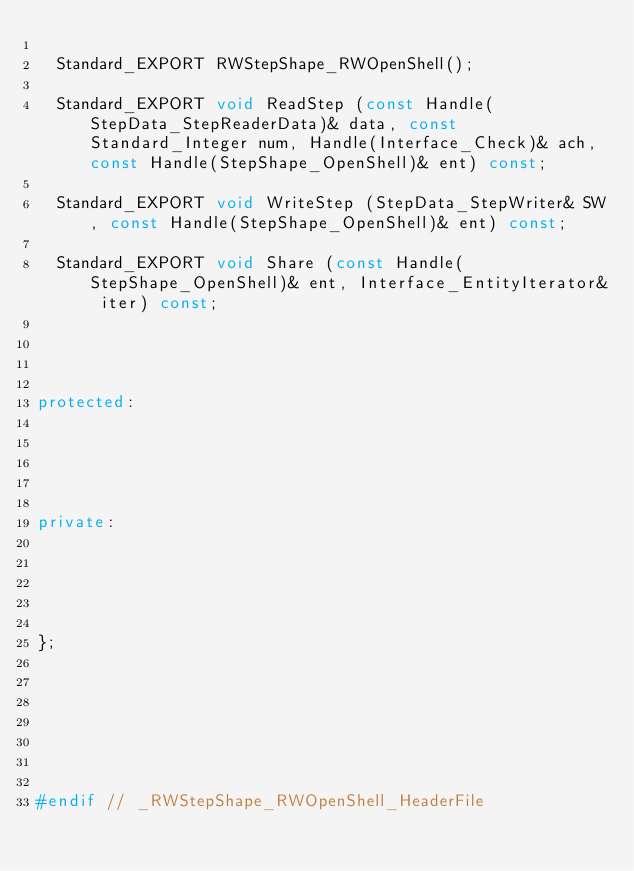Convert code to text. <code><loc_0><loc_0><loc_500><loc_500><_C++_>  
  Standard_EXPORT RWStepShape_RWOpenShell();
  
  Standard_EXPORT void ReadStep (const Handle(StepData_StepReaderData)& data, const Standard_Integer num, Handle(Interface_Check)& ach, const Handle(StepShape_OpenShell)& ent) const;
  
  Standard_EXPORT void WriteStep (StepData_StepWriter& SW, const Handle(StepShape_OpenShell)& ent) const;
  
  Standard_EXPORT void Share (const Handle(StepShape_OpenShell)& ent, Interface_EntityIterator& iter) const;




protected:





private:





};







#endif // _RWStepShape_RWOpenShell_HeaderFile
</code> 